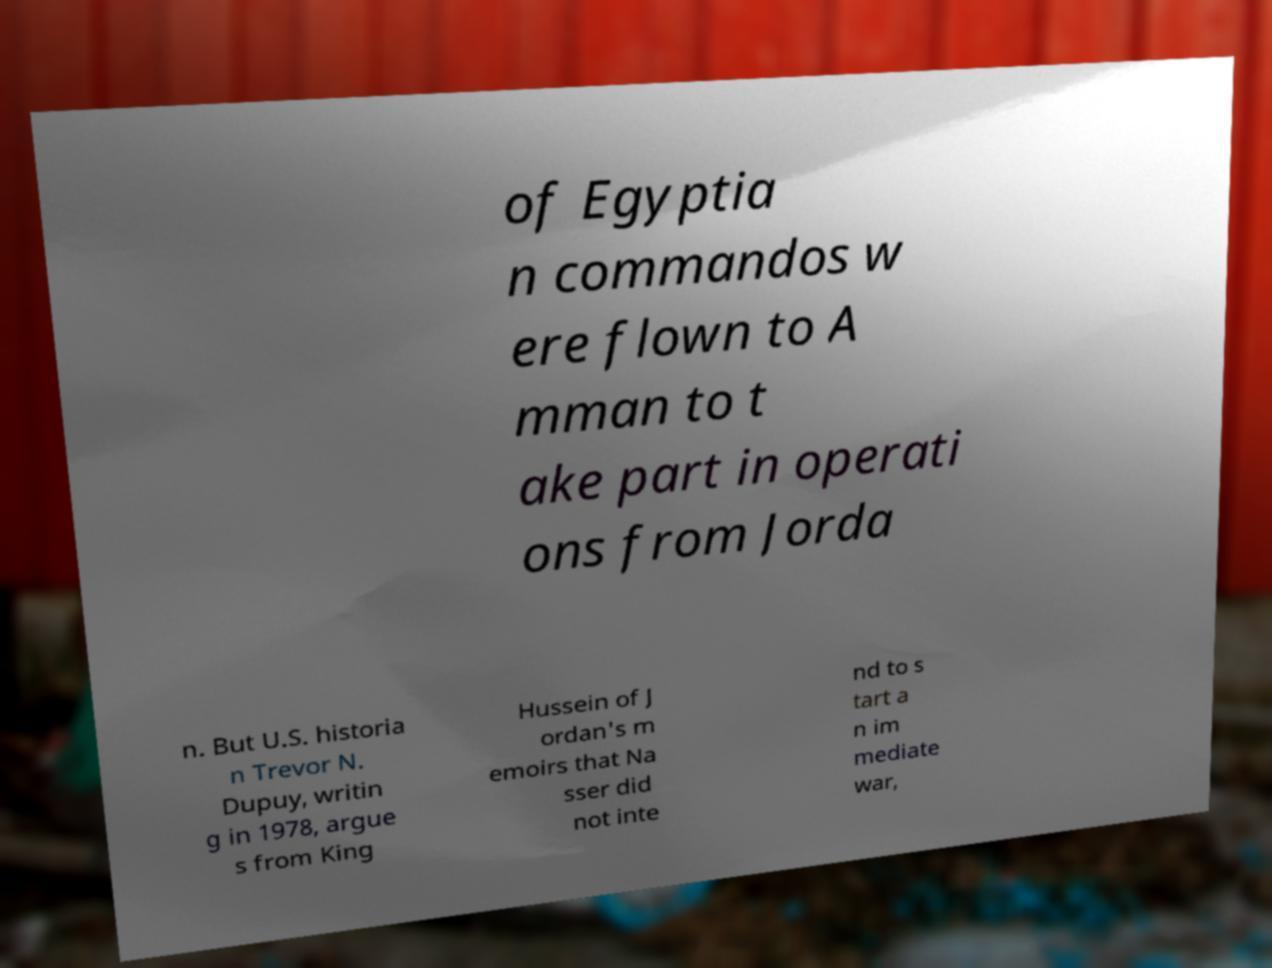Please read and relay the text visible in this image. What does it say? of Egyptia n commandos w ere flown to A mman to t ake part in operati ons from Jorda n. But U.S. historia n Trevor N. Dupuy, writin g in 1978, argue s from King Hussein of J ordan's m emoirs that Na sser did not inte nd to s tart a n im mediate war, 